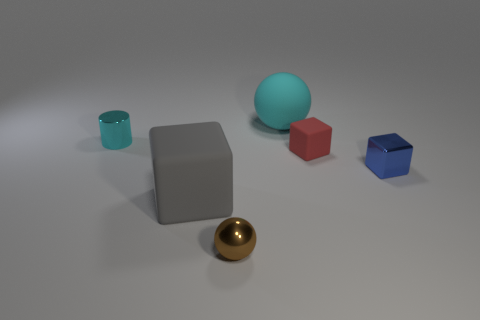What number of other objects are there of the same color as the tiny metal cylinder?
Offer a terse response. 1. Are there the same number of tiny red blocks to the right of the metal cube and small purple rubber things?
Your answer should be very brief. Yes. There is a rubber thing that is to the right of the large thing behind the tiny rubber cube; how many cylinders are right of it?
Give a very brief answer. 0. Is the size of the cyan cylinder the same as the metal object that is in front of the blue metallic block?
Provide a short and direct response. Yes. How many small yellow objects are there?
Your response must be concise. 0. There is a block behind the small blue object; does it have the same size as the matte block that is in front of the blue object?
Provide a short and direct response. No. There is another matte object that is the same shape as the red object; what is its color?
Provide a short and direct response. Gray. Is the tiny red matte object the same shape as the cyan shiny object?
Your answer should be very brief. No. The other thing that is the same shape as the big cyan matte object is what size?
Your answer should be compact. Small. What number of other tiny cyan objects are made of the same material as the small cyan thing?
Give a very brief answer. 0. 